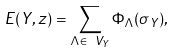<formula> <loc_0><loc_0><loc_500><loc_500>E ( Y , z ) = \sum _ { \Lambda \in \ V _ { Y } } \Phi _ { \Lambda } ( \sigma _ { Y } ) ,</formula> 